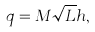Convert formula to latex. <formula><loc_0><loc_0><loc_500><loc_500>q = M \sqrt { L } h ,</formula> 